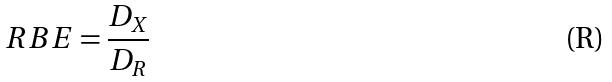Convert formula to latex. <formula><loc_0><loc_0><loc_500><loc_500>R B E = \frac { D _ { X } } { D _ { R } }</formula> 